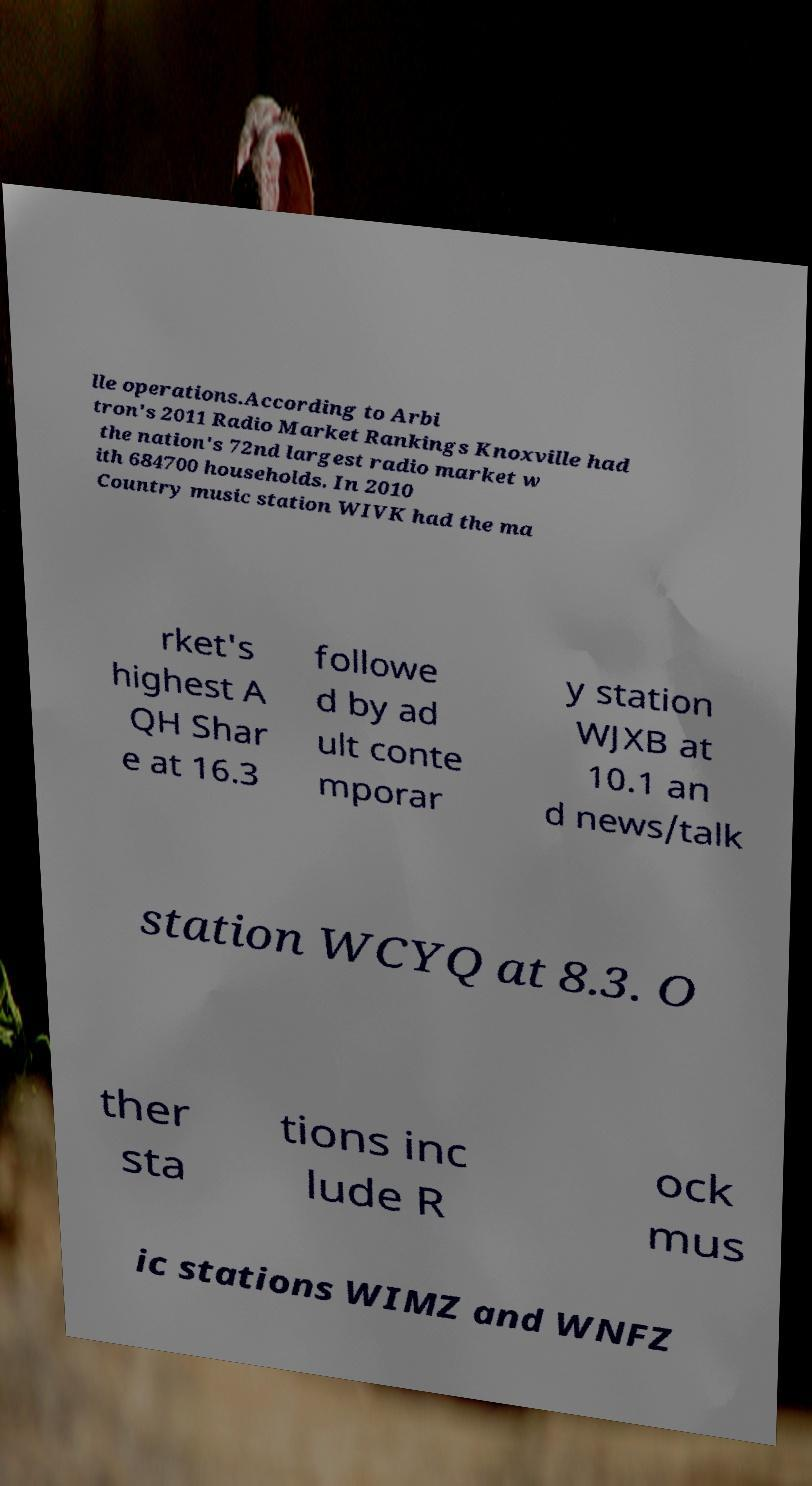I need the written content from this picture converted into text. Can you do that? lle operations.According to Arbi tron's 2011 Radio Market Rankings Knoxville had the nation's 72nd largest radio market w ith 684700 households. In 2010 Country music station WIVK had the ma rket's highest A QH Shar e at 16.3 followe d by ad ult conte mporar y station WJXB at 10.1 an d news/talk station WCYQ at 8.3. O ther sta tions inc lude R ock mus ic stations WIMZ and WNFZ 